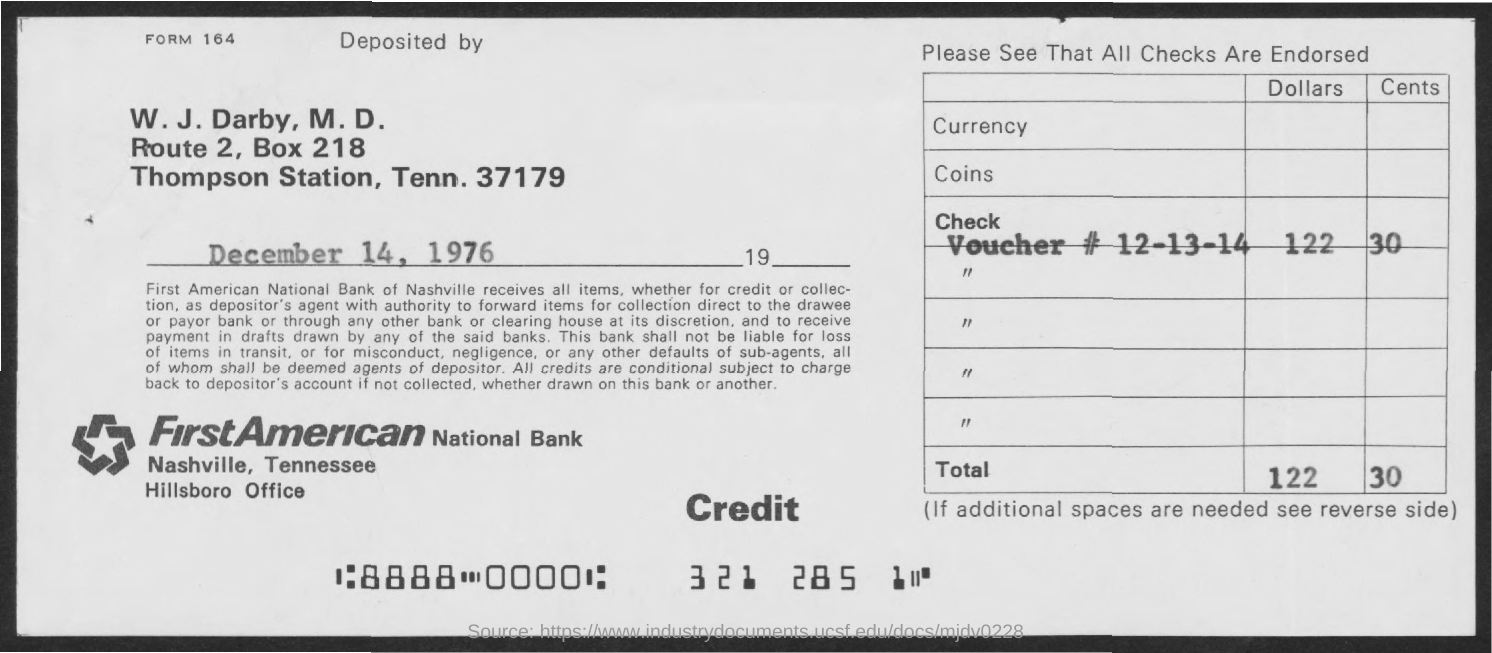What is the BOX Number ?
Your answer should be very brief. 218. 